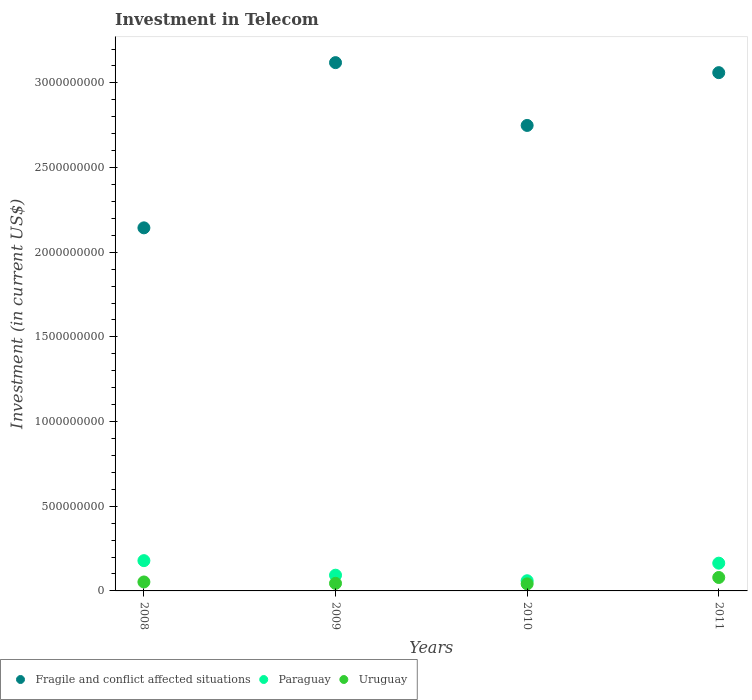How many different coloured dotlines are there?
Give a very brief answer. 3. Is the number of dotlines equal to the number of legend labels?
Make the answer very short. Yes. What is the amount invested in telecom in Paraguay in 2009?
Your answer should be compact. 9.29e+07. Across all years, what is the maximum amount invested in telecom in Paraguay?
Make the answer very short. 1.79e+08. Across all years, what is the minimum amount invested in telecom in Fragile and conflict affected situations?
Provide a succinct answer. 2.14e+09. In which year was the amount invested in telecom in Uruguay maximum?
Provide a succinct answer. 2011. What is the total amount invested in telecom in Fragile and conflict affected situations in the graph?
Keep it short and to the point. 1.11e+1. What is the difference between the amount invested in telecom in Uruguay in 2008 and that in 2009?
Make the answer very short. 8.20e+06. What is the difference between the amount invested in telecom in Fragile and conflict affected situations in 2009 and the amount invested in telecom in Uruguay in 2008?
Provide a succinct answer. 3.07e+09. What is the average amount invested in telecom in Uruguay per year?
Provide a succinct answer. 5.47e+07. In the year 2011, what is the difference between the amount invested in telecom in Paraguay and amount invested in telecom in Uruguay?
Give a very brief answer. 8.45e+07. In how many years, is the amount invested in telecom in Uruguay greater than 2400000000 US$?
Offer a terse response. 0. What is the ratio of the amount invested in telecom in Paraguay in 2008 to that in 2011?
Provide a succinct answer. 1.09. Is the amount invested in telecom in Paraguay in 2008 less than that in 2010?
Your response must be concise. No. Is the difference between the amount invested in telecom in Paraguay in 2008 and 2011 greater than the difference between the amount invested in telecom in Uruguay in 2008 and 2011?
Your answer should be compact. Yes. What is the difference between the highest and the second highest amount invested in telecom in Fragile and conflict affected situations?
Provide a short and direct response. 5.91e+07. What is the difference between the highest and the lowest amount invested in telecom in Fragile and conflict affected situations?
Ensure brevity in your answer.  9.76e+08. Is the sum of the amount invested in telecom in Uruguay in 2008 and 2009 greater than the maximum amount invested in telecom in Paraguay across all years?
Keep it short and to the point. No. How many dotlines are there?
Your response must be concise. 3. How many years are there in the graph?
Your answer should be compact. 4. What is the difference between two consecutive major ticks on the Y-axis?
Offer a terse response. 5.00e+08. Does the graph contain any zero values?
Make the answer very short. No. Where does the legend appear in the graph?
Your response must be concise. Bottom left. What is the title of the graph?
Provide a succinct answer. Investment in Telecom. Does "Afghanistan" appear as one of the legend labels in the graph?
Provide a succinct answer. No. What is the label or title of the X-axis?
Your answer should be compact. Years. What is the label or title of the Y-axis?
Provide a short and direct response. Investment (in current US$). What is the Investment (in current US$) in Fragile and conflict affected situations in 2008?
Provide a short and direct response. 2.14e+09. What is the Investment (in current US$) of Paraguay in 2008?
Make the answer very short. 1.79e+08. What is the Investment (in current US$) in Uruguay in 2008?
Offer a very short reply. 5.29e+07. What is the Investment (in current US$) in Fragile and conflict affected situations in 2009?
Offer a terse response. 3.12e+09. What is the Investment (in current US$) in Paraguay in 2009?
Make the answer very short. 9.29e+07. What is the Investment (in current US$) in Uruguay in 2009?
Your answer should be compact. 4.47e+07. What is the Investment (in current US$) of Fragile and conflict affected situations in 2010?
Give a very brief answer. 2.75e+09. What is the Investment (in current US$) of Paraguay in 2010?
Ensure brevity in your answer.  6.01e+07. What is the Investment (in current US$) of Uruguay in 2010?
Your answer should be very brief. 4.17e+07. What is the Investment (in current US$) in Fragile and conflict affected situations in 2011?
Keep it short and to the point. 3.06e+09. What is the Investment (in current US$) of Paraguay in 2011?
Give a very brief answer. 1.64e+08. What is the Investment (in current US$) of Uruguay in 2011?
Make the answer very short. 7.94e+07. Across all years, what is the maximum Investment (in current US$) in Fragile and conflict affected situations?
Your answer should be compact. 3.12e+09. Across all years, what is the maximum Investment (in current US$) of Paraguay?
Provide a succinct answer. 1.79e+08. Across all years, what is the maximum Investment (in current US$) in Uruguay?
Your answer should be very brief. 7.94e+07. Across all years, what is the minimum Investment (in current US$) in Fragile and conflict affected situations?
Provide a short and direct response. 2.14e+09. Across all years, what is the minimum Investment (in current US$) of Paraguay?
Your answer should be compact. 6.01e+07. Across all years, what is the minimum Investment (in current US$) in Uruguay?
Keep it short and to the point. 4.17e+07. What is the total Investment (in current US$) of Fragile and conflict affected situations in the graph?
Provide a short and direct response. 1.11e+1. What is the total Investment (in current US$) in Paraguay in the graph?
Make the answer very short. 4.96e+08. What is the total Investment (in current US$) in Uruguay in the graph?
Provide a succinct answer. 2.19e+08. What is the difference between the Investment (in current US$) in Fragile and conflict affected situations in 2008 and that in 2009?
Give a very brief answer. -9.76e+08. What is the difference between the Investment (in current US$) in Paraguay in 2008 and that in 2009?
Provide a succinct answer. 8.59e+07. What is the difference between the Investment (in current US$) in Uruguay in 2008 and that in 2009?
Offer a very short reply. 8.20e+06. What is the difference between the Investment (in current US$) of Fragile and conflict affected situations in 2008 and that in 2010?
Provide a short and direct response. -6.05e+08. What is the difference between the Investment (in current US$) of Paraguay in 2008 and that in 2010?
Provide a succinct answer. 1.19e+08. What is the difference between the Investment (in current US$) in Uruguay in 2008 and that in 2010?
Make the answer very short. 1.12e+07. What is the difference between the Investment (in current US$) of Fragile and conflict affected situations in 2008 and that in 2011?
Your response must be concise. -9.16e+08. What is the difference between the Investment (in current US$) in Paraguay in 2008 and that in 2011?
Offer a very short reply. 1.49e+07. What is the difference between the Investment (in current US$) of Uruguay in 2008 and that in 2011?
Your answer should be very brief. -2.65e+07. What is the difference between the Investment (in current US$) in Fragile and conflict affected situations in 2009 and that in 2010?
Give a very brief answer. 3.71e+08. What is the difference between the Investment (in current US$) of Paraguay in 2009 and that in 2010?
Keep it short and to the point. 3.28e+07. What is the difference between the Investment (in current US$) of Uruguay in 2009 and that in 2010?
Provide a short and direct response. 3.00e+06. What is the difference between the Investment (in current US$) in Fragile and conflict affected situations in 2009 and that in 2011?
Ensure brevity in your answer.  5.91e+07. What is the difference between the Investment (in current US$) of Paraguay in 2009 and that in 2011?
Make the answer very short. -7.10e+07. What is the difference between the Investment (in current US$) of Uruguay in 2009 and that in 2011?
Keep it short and to the point. -3.47e+07. What is the difference between the Investment (in current US$) of Fragile and conflict affected situations in 2010 and that in 2011?
Your response must be concise. -3.12e+08. What is the difference between the Investment (in current US$) in Paraguay in 2010 and that in 2011?
Ensure brevity in your answer.  -1.04e+08. What is the difference between the Investment (in current US$) in Uruguay in 2010 and that in 2011?
Your answer should be very brief. -3.77e+07. What is the difference between the Investment (in current US$) in Fragile and conflict affected situations in 2008 and the Investment (in current US$) in Paraguay in 2009?
Make the answer very short. 2.05e+09. What is the difference between the Investment (in current US$) in Fragile and conflict affected situations in 2008 and the Investment (in current US$) in Uruguay in 2009?
Your answer should be compact. 2.10e+09. What is the difference between the Investment (in current US$) in Paraguay in 2008 and the Investment (in current US$) in Uruguay in 2009?
Your answer should be very brief. 1.34e+08. What is the difference between the Investment (in current US$) in Fragile and conflict affected situations in 2008 and the Investment (in current US$) in Paraguay in 2010?
Provide a succinct answer. 2.08e+09. What is the difference between the Investment (in current US$) of Fragile and conflict affected situations in 2008 and the Investment (in current US$) of Uruguay in 2010?
Offer a very short reply. 2.10e+09. What is the difference between the Investment (in current US$) of Paraguay in 2008 and the Investment (in current US$) of Uruguay in 2010?
Provide a short and direct response. 1.37e+08. What is the difference between the Investment (in current US$) in Fragile and conflict affected situations in 2008 and the Investment (in current US$) in Paraguay in 2011?
Your response must be concise. 1.98e+09. What is the difference between the Investment (in current US$) of Fragile and conflict affected situations in 2008 and the Investment (in current US$) of Uruguay in 2011?
Make the answer very short. 2.06e+09. What is the difference between the Investment (in current US$) in Paraguay in 2008 and the Investment (in current US$) in Uruguay in 2011?
Give a very brief answer. 9.94e+07. What is the difference between the Investment (in current US$) of Fragile and conflict affected situations in 2009 and the Investment (in current US$) of Paraguay in 2010?
Offer a very short reply. 3.06e+09. What is the difference between the Investment (in current US$) in Fragile and conflict affected situations in 2009 and the Investment (in current US$) in Uruguay in 2010?
Give a very brief answer. 3.08e+09. What is the difference between the Investment (in current US$) of Paraguay in 2009 and the Investment (in current US$) of Uruguay in 2010?
Offer a terse response. 5.12e+07. What is the difference between the Investment (in current US$) of Fragile and conflict affected situations in 2009 and the Investment (in current US$) of Paraguay in 2011?
Your answer should be compact. 2.96e+09. What is the difference between the Investment (in current US$) in Fragile and conflict affected situations in 2009 and the Investment (in current US$) in Uruguay in 2011?
Your answer should be compact. 3.04e+09. What is the difference between the Investment (in current US$) of Paraguay in 2009 and the Investment (in current US$) of Uruguay in 2011?
Offer a very short reply. 1.35e+07. What is the difference between the Investment (in current US$) in Fragile and conflict affected situations in 2010 and the Investment (in current US$) in Paraguay in 2011?
Your answer should be very brief. 2.58e+09. What is the difference between the Investment (in current US$) of Fragile and conflict affected situations in 2010 and the Investment (in current US$) of Uruguay in 2011?
Your answer should be very brief. 2.67e+09. What is the difference between the Investment (in current US$) in Paraguay in 2010 and the Investment (in current US$) in Uruguay in 2011?
Your answer should be very brief. -1.93e+07. What is the average Investment (in current US$) of Fragile and conflict affected situations per year?
Keep it short and to the point. 2.77e+09. What is the average Investment (in current US$) of Paraguay per year?
Offer a terse response. 1.24e+08. What is the average Investment (in current US$) in Uruguay per year?
Keep it short and to the point. 5.47e+07. In the year 2008, what is the difference between the Investment (in current US$) in Fragile and conflict affected situations and Investment (in current US$) in Paraguay?
Your response must be concise. 1.97e+09. In the year 2008, what is the difference between the Investment (in current US$) of Fragile and conflict affected situations and Investment (in current US$) of Uruguay?
Offer a terse response. 2.09e+09. In the year 2008, what is the difference between the Investment (in current US$) in Paraguay and Investment (in current US$) in Uruguay?
Provide a succinct answer. 1.26e+08. In the year 2009, what is the difference between the Investment (in current US$) of Fragile and conflict affected situations and Investment (in current US$) of Paraguay?
Keep it short and to the point. 3.03e+09. In the year 2009, what is the difference between the Investment (in current US$) in Fragile and conflict affected situations and Investment (in current US$) in Uruguay?
Offer a terse response. 3.07e+09. In the year 2009, what is the difference between the Investment (in current US$) of Paraguay and Investment (in current US$) of Uruguay?
Your answer should be compact. 4.82e+07. In the year 2010, what is the difference between the Investment (in current US$) of Fragile and conflict affected situations and Investment (in current US$) of Paraguay?
Provide a succinct answer. 2.69e+09. In the year 2010, what is the difference between the Investment (in current US$) in Fragile and conflict affected situations and Investment (in current US$) in Uruguay?
Keep it short and to the point. 2.71e+09. In the year 2010, what is the difference between the Investment (in current US$) in Paraguay and Investment (in current US$) in Uruguay?
Make the answer very short. 1.84e+07. In the year 2011, what is the difference between the Investment (in current US$) in Fragile and conflict affected situations and Investment (in current US$) in Paraguay?
Your answer should be compact. 2.90e+09. In the year 2011, what is the difference between the Investment (in current US$) in Fragile and conflict affected situations and Investment (in current US$) in Uruguay?
Your answer should be very brief. 2.98e+09. In the year 2011, what is the difference between the Investment (in current US$) of Paraguay and Investment (in current US$) of Uruguay?
Provide a short and direct response. 8.45e+07. What is the ratio of the Investment (in current US$) in Fragile and conflict affected situations in 2008 to that in 2009?
Your answer should be compact. 0.69. What is the ratio of the Investment (in current US$) of Paraguay in 2008 to that in 2009?
Your response must be concise. 1.92. What is the ratio of the Investment (in current US$) of Uruguay in 2008 to that in 2009?
Make the answer very short. 1.18. What is the ratio of the Investment (in current US$) of Fragile and conflict affected situations in 2008 to that in 2010?
Offer a very short reply. 0.78. What is the ratio of the Investment (in current US$) of Paraguay in 2008 to that in 2010?
Provide a succinct answer. 2.98. What is the ratio of the Investment (in current US$) in Uruguay in 2008 to that in 2010?
Keep it short and to the point. 1.27. What is the ratio of the Investment (in current US$) of Fragile and conflict affected situations in 2008 to that in 2011?
Provide a succinct answer. 0.7. What is the ratio of the Investment (in current US$) of Paraguay in 2008 to that in 2011?
Your answer should be compact. 1.09. What is the ratio of the Investment (in current US$) in Uruguay in 2008 to that in 2011?
Make the answer very short. 0.67. What is the ratio of the Investment (in current US$) of Fragile and conflict affected situations in 2009 to that in 2010?
Keep it short and to the point. 1.13. What is the ratio of the Investment (in current US$) in Paraguay in 2009 to that in 2010?
Offer a very short reply. 1.55. What is the ratio of the Investment (in current US$) of Uruguay in 2009 to that in 2010?
Your answer should be very brief. 1.07. What is the ratio of the Investment (in current US$) of Fragile and conflict affected situations in 2009 to that in 2011?
Provide a succinct answer. 1.02. What is the ratio of the Investment (in current US$) of Paraguay in 2009 to that in 2011?
Ensure brevity in your answer.  0.57. What is the ratio of the Investment (in current US$) in Uruguay in 2009 to that in 2011?
Offer a terse response. 0.56. What is the ratio of the Investment (in current US$) of Fragile and conflict affected situations in 2010 to that in 2011?
Your answer should be very brief. 0.9. What is the ratio of the Investment (in current US$) of Paraguay in 2010 to that in 2011?
Give a very brief answer. 0.37. What is the ratio of the Investment (in current US$) of Uruguay in 2010 to that in 2011?
Make the answer very short. 0.53. What is the difference between the highest and the second highest Investment (in current US$) in Fragile and conflict affected situations?
Your answer should be compact. 5.91e+07. What is the difference between the highest and the second highest Investment (in current US$) of Paraguay?
Make the answer very short. 1.49e+07. What is the difference between the highest and the second highest Investment (in current US$) of Uruguay?
Make the answer very short. 2.65e+07. What is the difference between the highest and the lowest Investment (in current US$) of Fragile and conflict affected situations?
Offer a very short reply. 9.76e+08. What is the difference between the highest and the lowest Investment (in current US$) of Paraguay?
Offer a very short reply. 1.19e+08. What is the difference between the highest and the lowest Investment (in current US$) of Uruguay?
Keep it short and to the point. 3.77e+07. 